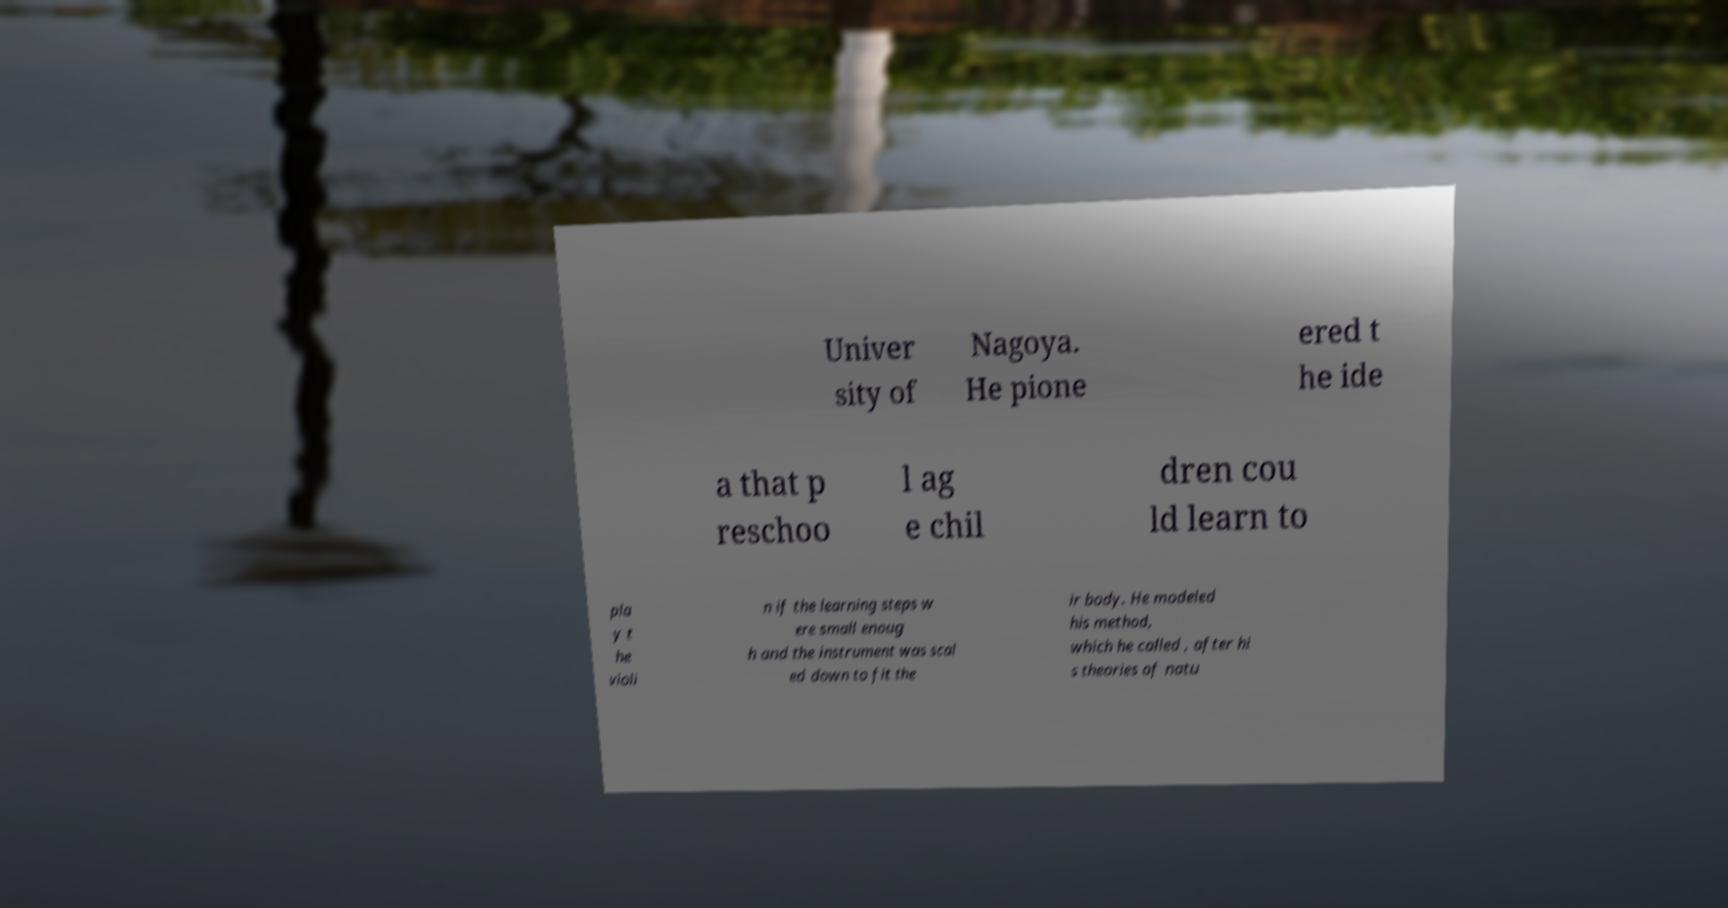Can you read and provide the text displayed in the image?This photo seems to have some interesting text. Can you extract and type it out for me? Univer sity of Nagoya. He pione ered t he ide a that p reschoo l ag e chil dren cou ld learn to pla y t he violi n if the learning steps w ere small enoug h and the instrument was scal ed down to fit the ir body. He modeled his method, which he called , after hi s theories of natu 